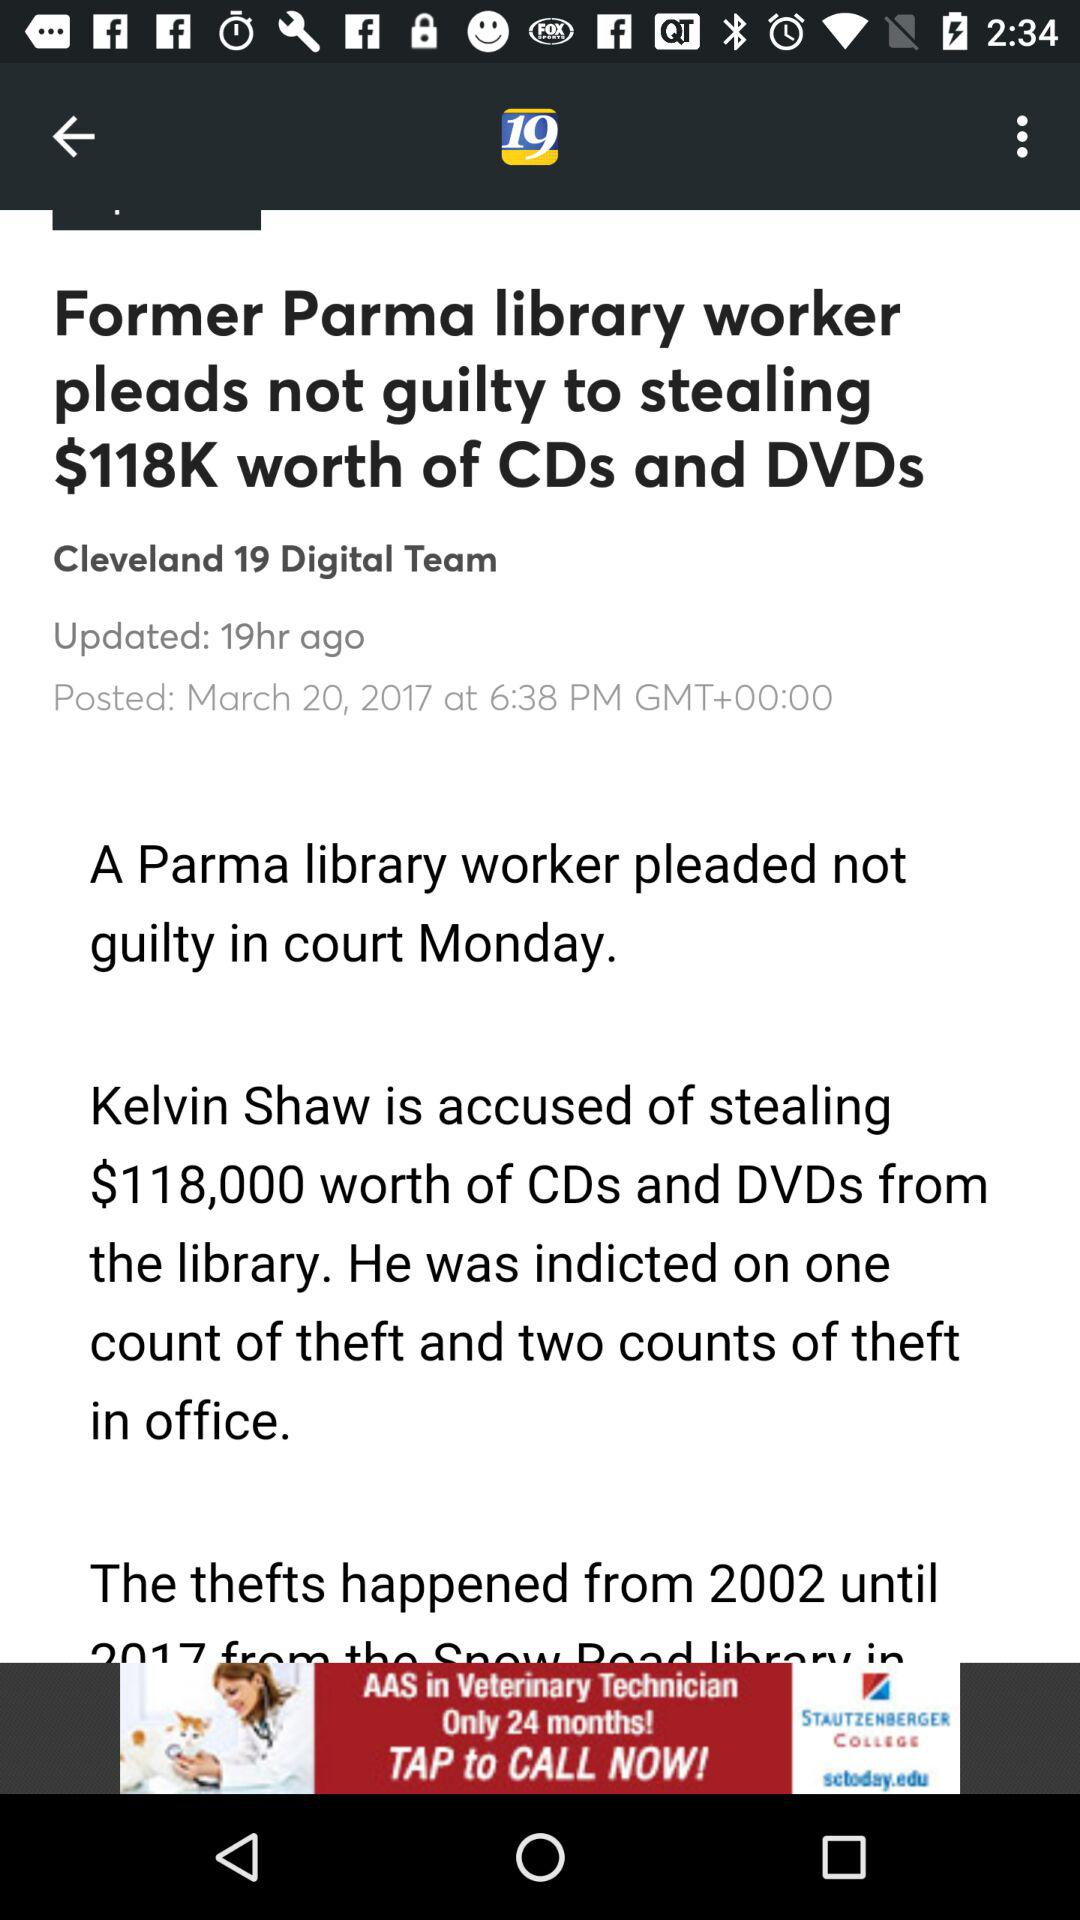What is the posted date and time? The posted date and time are March 20, 2017 at 6:38 PM GMT+00:00, respectively. 